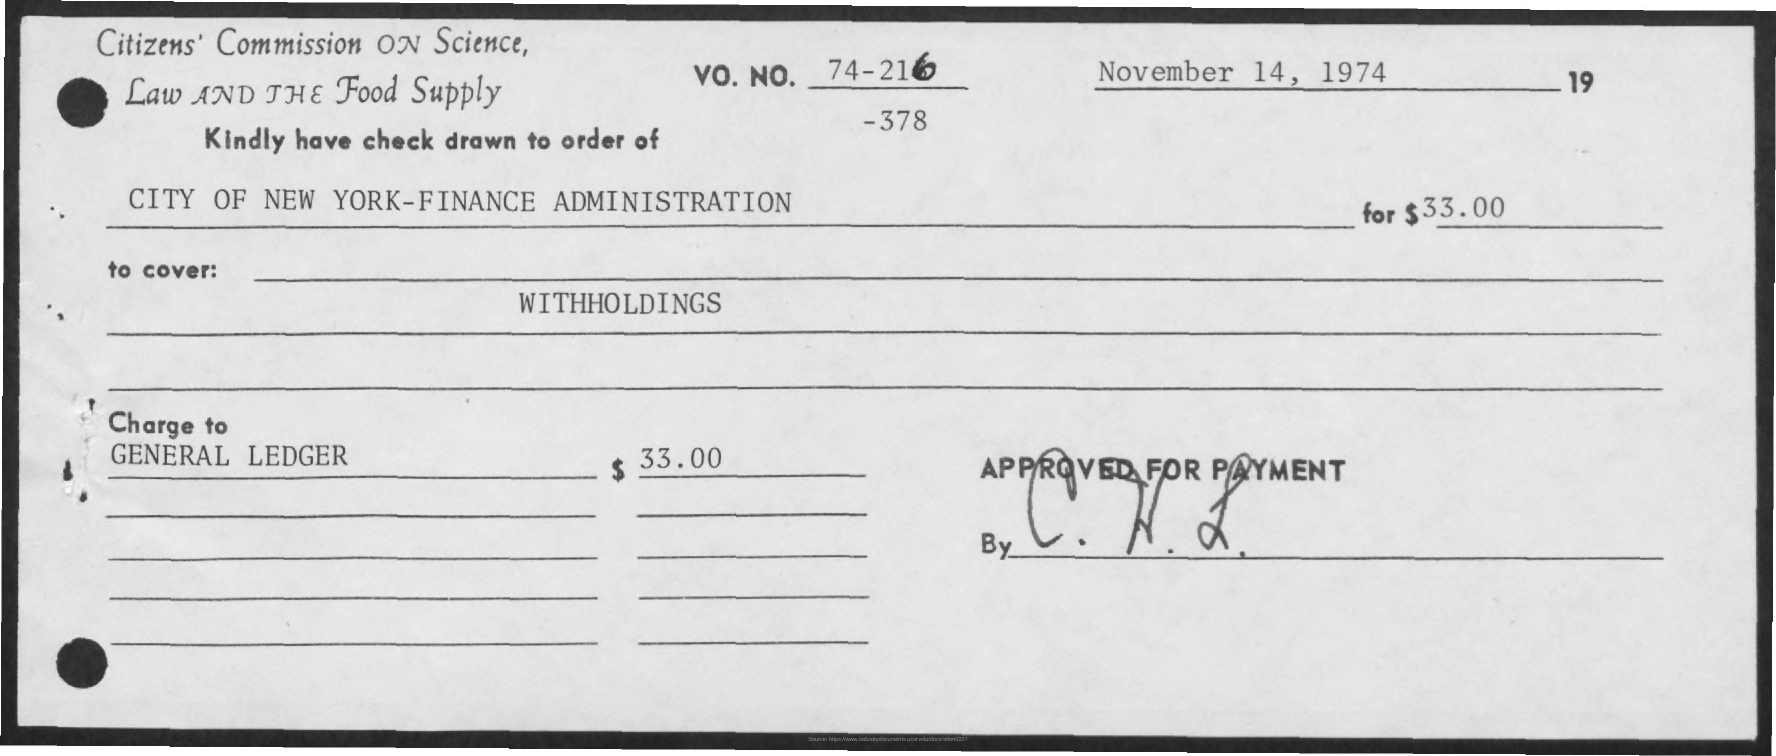Can you tell me the date when the cheque was issued? The cheque was issued on November 14, 1974, as indicated at the top right corner of the document. 